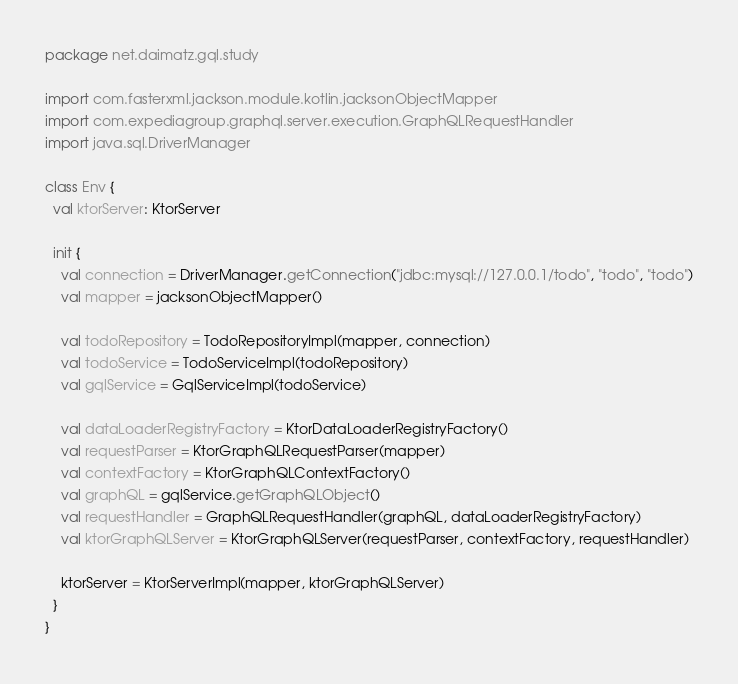Convert code to text. <code><loc_0><loc_0><loc_500><loc_500><_Kotlin_>
package net.daimatz.gql.study

import com.fasterxml.jackson.module.kotlin.jacksonObjectMapper
import com.expediagroup.graphql.server.execution.GraphQLRequestHandler
import java.sql.DriverManager

class Env {
  val ktorServer: KtorServer

  init {
    val connection = DriverManager.getConnection("jdbc:mysql://127.0.0.1/todo", "todo", "todo")
    val mapper = jacksonObjectMapper()

    val todoRepository = TodoRepositoryImpl(mapper, connection)
    val todoService = TodoServiceImpl(todoRepository)
    val gqlService = GqlServiceImpl(todoService)

    val dataLoaderRegistryFactory = KtorDataLoaderRegistryFactory()
    val requestParser = KtorGraphQLRequestParser(mapper)
    val contextFactory = KtorGraphQLContextFactory()
    val graphQL = gqlService.getGraphQLObject()
    val requestHandler = GraphQLRequestHandler(graphQL, dataLoaderRegistryFactory)
    val ktorGraphQLServer = KtorGraphQLServer(requestParser, contextFactory, requestHandler)

    ktorServer = KtorServerImpl(mapper, ktorGraphQLServer)
  }
}
</code> 